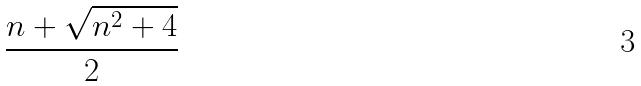Convert formula to latex. <formula><loc_0><loc_0><loc_500><loc_500>\frac { n + \sqrt { n ^ { 2 } + 4 } } { 2 }</formula> 